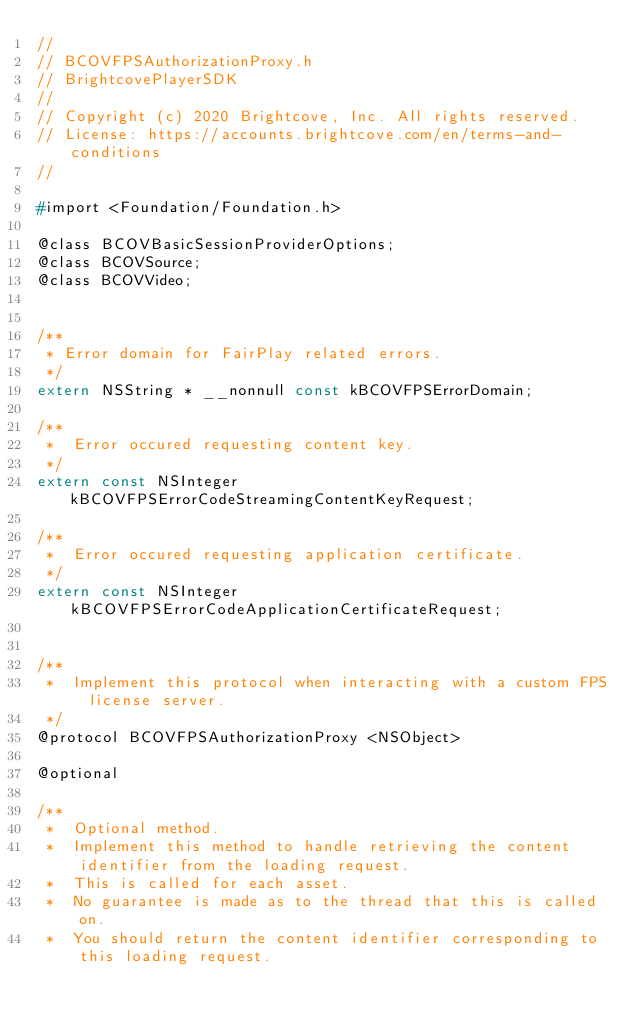Convert code to text. <code><loc_0><loc_0><loc_500><loc_500><_C_>//
// BCOVFPSAuthorizationProxy.h
// BrightcovePlayerSDK
//
// Copyright (c) 2020 Brightcove, Inc. All rights reserved.
// License: https://accounts.brightcove.com/en/terms-and-conditions
//

#import <Foundation/Foundation.h>

@class BCOVBasicSessionProviderOptions;
@class BCOVSource;
@class BCOVVideo;


/**
 * Error domain for FairPlay related errors.
 */
extern NSString * __nonnull const kBCOVFPSErrorDomain;

/**
 *  Error occured requesting content key.
 */
extern const NSInteger kBCOVFPSErrorCodeStreamingContentKeyRequest;

/**
 *  Error occured requesting application certificate.
 */
extern const NSInteger kBCOVFPSErrorCodeApplicationCertificateRequest;


/**
 *  Implement this protocol when interacting with a custom FPS license server.
 */
@protocol BCOVFPSAuthorizationProxy <NSObject>

@optional

/**
 *  Optional method.
 *  Implement this method to handle retrieving the content identifier from the loading request.
 *  This is called for each asset.
 *  No guarantee is made as to the thread that this is called on.
 *  You should return the content identifier corresponding to this loading request.</code> 